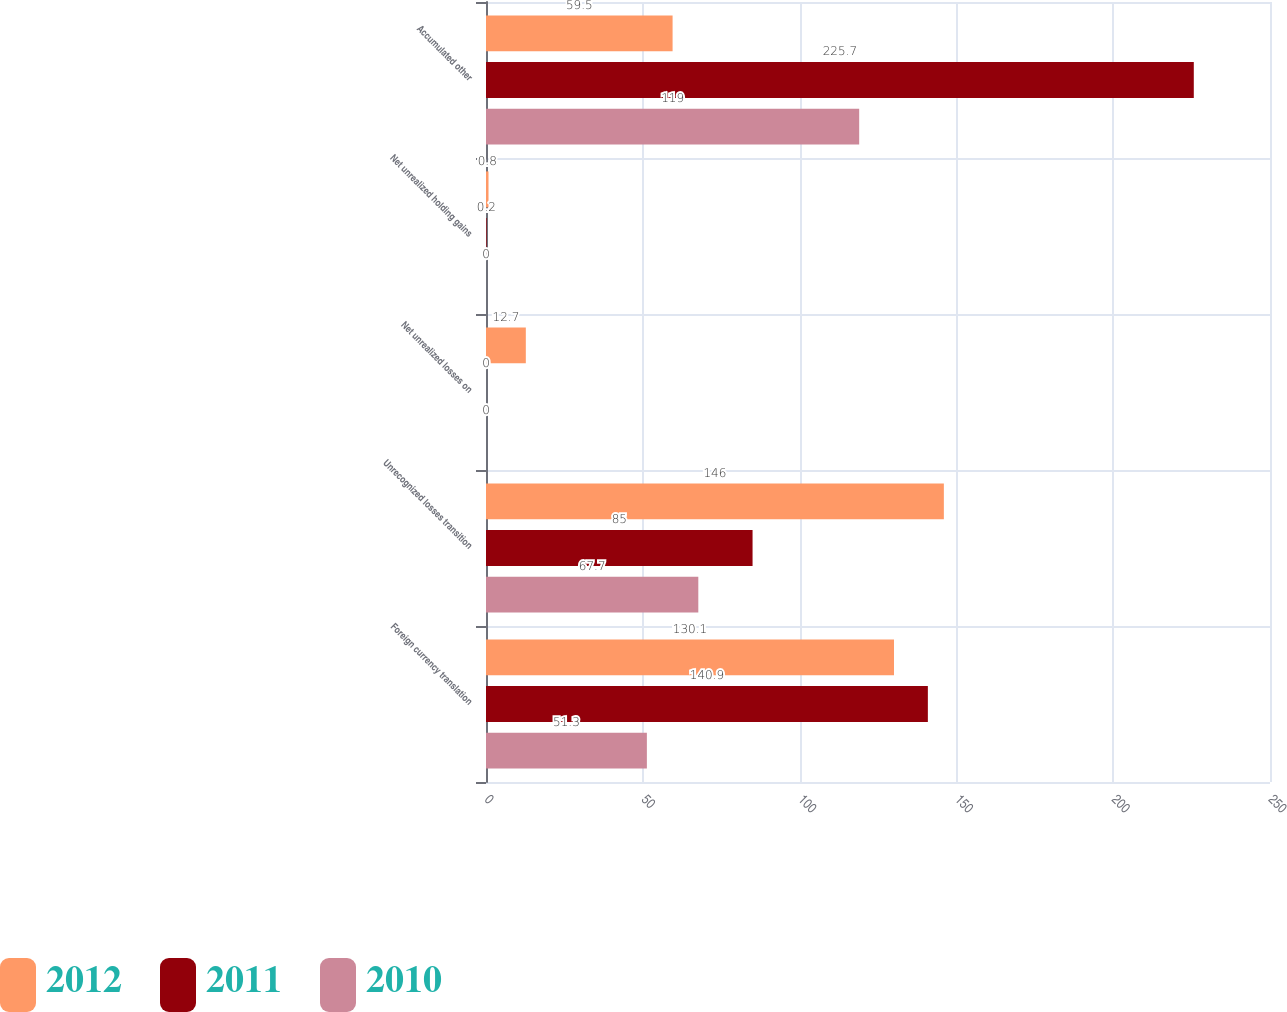<chart> <loc_0><loc_0><loc_500><loc_500><stacked_bar_chart><ecel><fcel>Foreign currency translation<fcel>Unrecognized losses transition<fcel>Net unrealized losses on<fcel>Net unrealized holding gains<fcel>Accumulated other<nl><fcel>2012<fcel>130.1<fcel>146<fcel>12.7<fcel>0.8<fcel>59.5<nl><fcel>2011<fcel>140.9<fcel>85<fcel>0<fcel>0.2<fcel>225.7<nl><fcel>2010<fcel>51.3<fcel>67.7<fcel>0<fcel>0<fcel>119<nl></chart> 